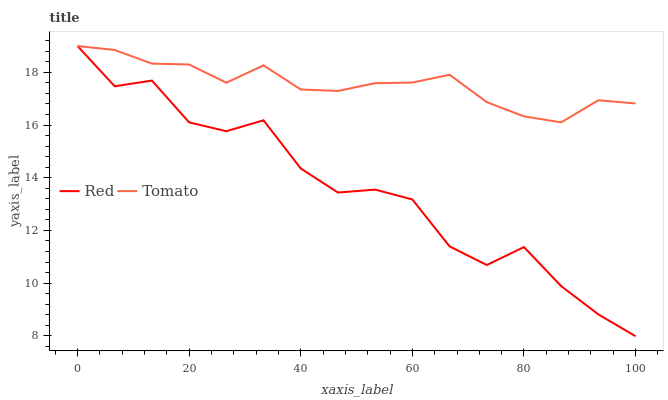Does Red have the maximum area under the curve?
Answer yes or no. No. Is Red the smoothest?
Answer yes or no. No. 